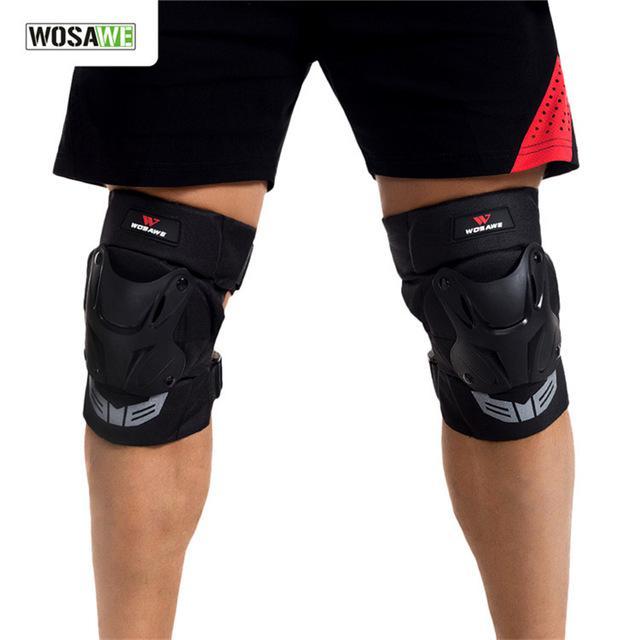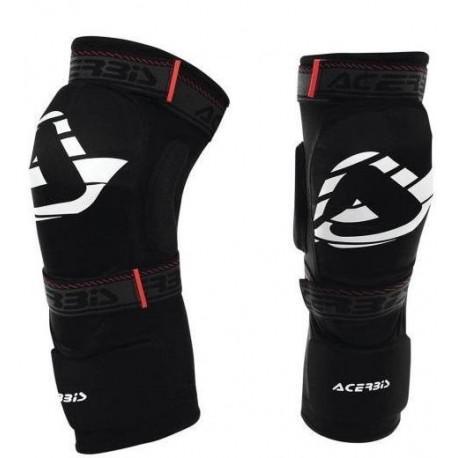The first image is the image on the left, the second image is the image on the right. Analyze the images presented: Is the assertion "The left and right image contains the same number of knee pads." valid? Answer yes or no. Yes. The first image is the image on the left, the second image is the image on the right. For the images shown, is this caption "One image shows a pair of legs in shorts wearing a pair of black knee pads, and the other image features an unworn pair of black kneepads." true? Answer yes or no. Yes. 